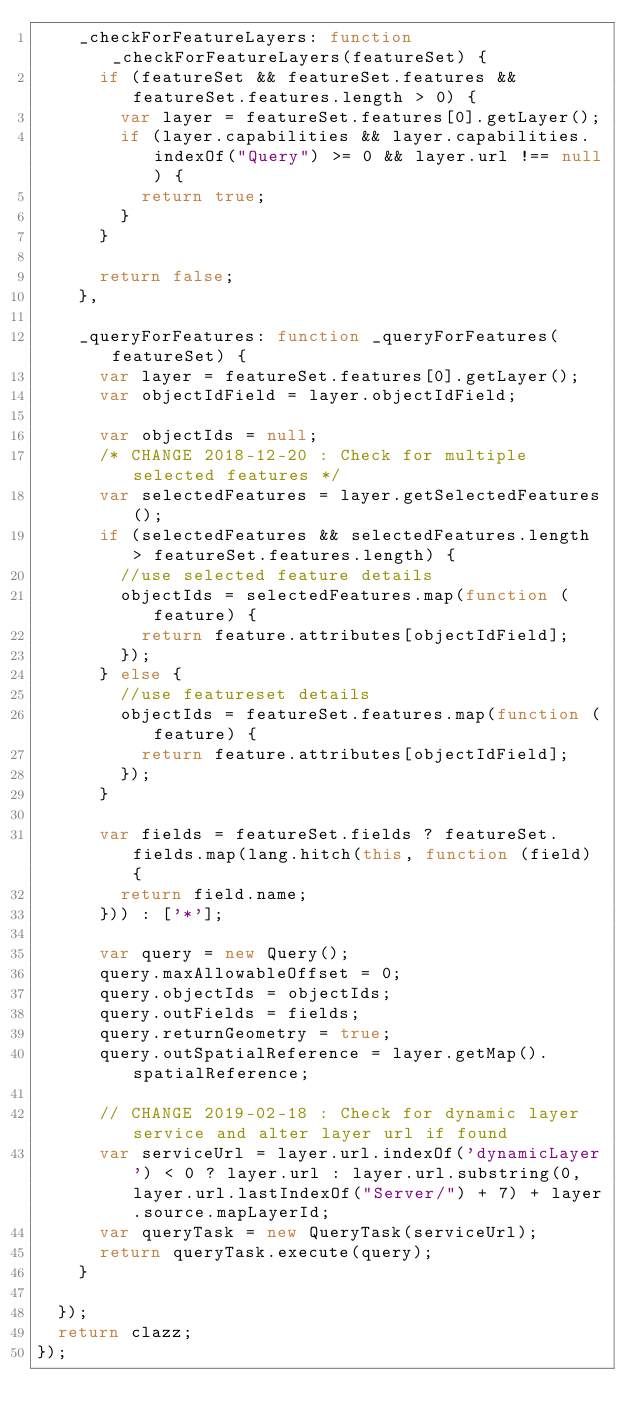Convert code to text. <code><loc_0><loc_0><loc_500><loc_500><_JavaScript_>    _checkForFeatureLayers: function _checkForFeatureLayers(featureSet) {
      if (featureSet && featureSet.features && featureSet.features.length > 0) {
        var layer = featureSet.features[0].getLayer();
        if (layer.capabilities && layer.capabilities.indexOf("Query") >= 0 && layer.url !== null) {
          return true;
        }
      }

      return false;
    },

    _queryForFeatures: function _queryForFeatures(featureSet) {
      var layer = featureSet.features[0].getLayer();
      var objectIdField = layer.objectIdField;

      var objectIds = null;
      /* CHANGE 2018-12-20 : Check for multiple selected features */
      var selectedFeatures = layer.getSelectedFeatures();
      if (selectedFeatures && selectedFeatures.length > featureSet.features.length) {
        //use selected feature details
        objectIds = selectedFeatures.map(function (feature) {
          return feature.attributes[objectIdField];
        });
      } else {
        //use featureset details
        objectIds = featureSet.features.map(function (feature) {
          return feature.attributes[objectIdField];
        });
      }

      var fields = featureSet.fields ? featureSet.fields.map(lang.hitch(this, function (field) {
        return field.name;
      })) : ['*'];

      var query = new Query();
      query.maxAllowableOffset = 0;
      query.objectIds = objectIds;
      query.outFields = fields;
      query.returnGeometry = true;
      query.outSpatialReference = layer.getMap().spatialReference;

      // CHANGE 2019-02-18 : Check for dynamic layer service and alter layer url if found 
      var serviceUrl = layer.url.indexOf('dynamicLayer') < 0 ? layer.url : layer.url.substring(0, layer.url.lastIndexOf("Server/") + 7) + layer.source.mapLayerId;
      var queryTask = new QueryTask(serviceUrl);
      return queryTask.execute(query);
    }

  });
  return clazz;
});
</code> 